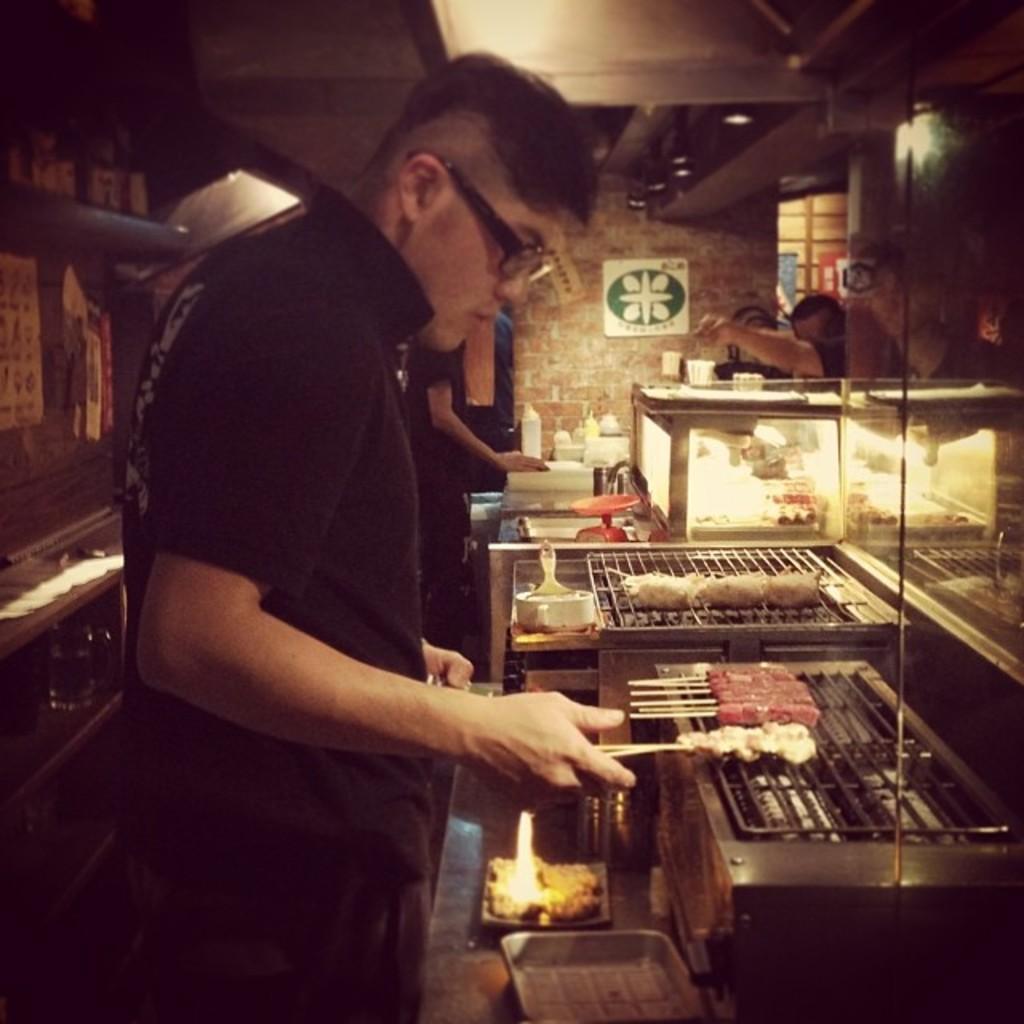Describe this image in one or two sentences. In this image we can see few persons. On the right side, we can see food items on the grills and few objects on the table. In the background, we can see a wall. On the wall we can see a poster with images. On the left side, we can see a wall and there are a few posts on the wall. At the top we can see the roof. 